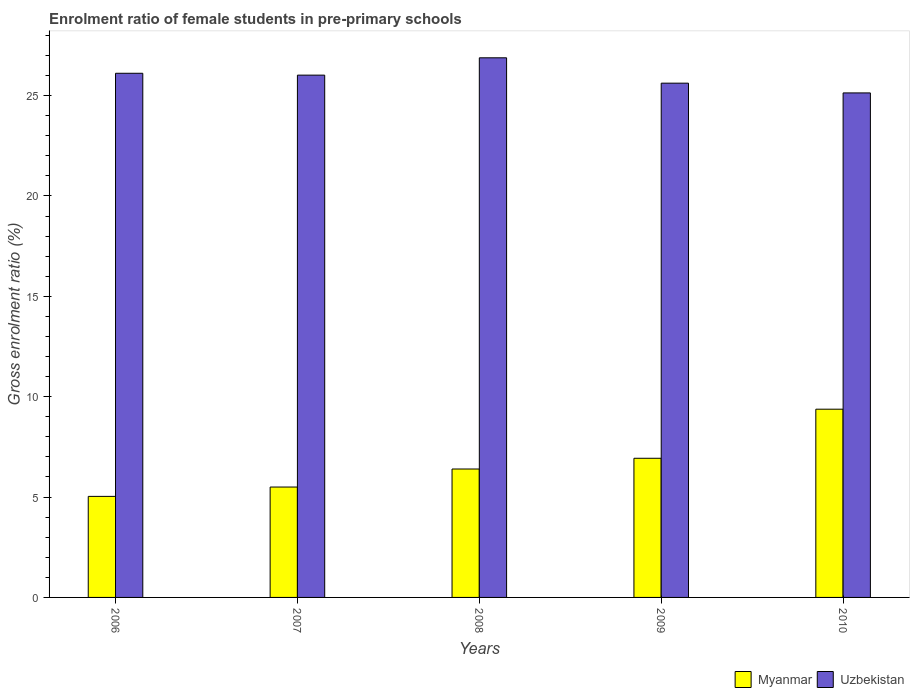How many groups of bars are there?
Provide a succinct answer. 5. Are the number of bars per tick equal to the number of legend labels?
Provide a short and direct response. Yes. Are the number of bars on each tick of the X-axis equal?
Your response must be concise. Yes. How many bars are there on the 2nd tick from the left?
Make the answer very short. 2. How many bars are there on the 1st tick from the right?
Offer a terse response. 2. What is the label of the 1st group of bars from the left?
Provide a succinct answer. 2006. In how many cases, is the number of bars for a given year not equal to the number of legend labels?
Your response must be concise. 0. What is the enrolment ratio of female students in pre-primary schools in Uzbekistan in 2008?
Keep it short and to the point. 26.88. Across all years, what is the maximum enrolment ratio of female students in pre-primary schools in Myanmar?
Your answer should be compact. 9.38. Across all years, what is the minimum enrolment ratio of female students in pre-primary schools in Uzbekistan?
Ensure brevity in your answer.  25.13. What is the total enrolment ratio of female students in pre-primary schools in Myanmar in the graph?
Give a very brief answer. 33.24. What is the difference between the enrolment ratio of female students in pre-primary schools in Uzbekistan in 2008 and that in 2010?
Your answer should be very brief. 1.75. What is the difference between the enrolment ratio of female students in pre-primary schools in Myanmar in 2008 and the enrolment ratio of female students in pre-primary schools in Uzbekistan in 2006?
Ensure brevity in your answer.  -19.71. What is the average enrolment ratio of female students in pre-primary schools in Uzbekistan per year?
Your answer should be compact. 25.95. In the year 2010, what is the difference between the enrolment ratio of female students in pre-primary schools in Uzbekistan and enrolment ratio of female students in pre-primary schools in Myanmar?
Make the answer very short. 15.76. What is the ratio of the enrolment ratio of female students in pre-primary schools in Uzbekistan in 2006 to that in 2007?
Your answer should be compact. 1. What is the difference between the highest and the second highest enrolment ratio of female students in pre-primary schools in Myanmar?
Keep it short and to the point. 2.44. What is the difference between the highest and the lowest enrolment ratio of female students in pre-primary schools in Uzbekistan?
Provide a short and direct response. 1.75. In how many years, is the enrolment ratio of female students in pre-primary schools in Uzbekistan greater than the average enrolment ratio of female students in pre-primary schools in Uzbekistan taken over all years?
Give a very brief answer. 3. Is the sum of the enrolment ratio of female students in pre-primary schools in Myanmar in 2009 and 2010 greater than the maximum enrolment ratio of female students in pre-primary schools in Uzbekistan across all years?
Offer a terse response. No. What does the 2nd bar from the left in 2009 represents?
Offer a terse response. Uzbekistan. What does the 1st bar from the right in 2010 represents?
Provide a short and direct response. Uzbekistan. How many bars are there?
Your response must be concise. 10. Are all the bars in the graph horizontal?
Keep it short and to the point. No. What is the difference between two consecutive major ticks on the Y-axis?
Ensure brevity in your answer.  5. Where does the legend appear in the graph?
Provide a succinct answer. Bottom right. How are the legend labels stacked?
Provide a succinct answer. Horizontal. What is the title of the graph?
Offer a very short reply. Enrolment ratio of female students in pre-primary schools. Does "Zimbabwe" appear as one of the legend labels in the graph?
Give a very brief answer. No. What is the label or title of the X-axis?
Offer a terse response. Years. What is the label or title of the Y-axis?
Make the answer very short. Gross enrolment ratio (%). What is the Gross enrolment ratio (%) of Myanmar in 2006?
Keep it short and to the point. 5.03. What is the Gross enrolment ratio (%) in Uzbekistan in 2006?
Your answer should be very brief. 26.11. What is the Gross enrolment ratio (%) in Myanmar in 2007?
Your answer should be compact. 5.5. What is the Gross enrolment ratio (%) in Uzbekistan in 2007?
Ensure brevity in your answer.  26.02. What is the Gross enrolment ratio (%) in Myanmar in 2008?
Provide a short and direct response. 6.4. What is the Gross enrolment ratio (%) of Uzbekistan in 2008?
Provide a short and direct response. 26.88. What is the Gross enrolment ratio (%) in Myanmar in 2009?
Offer a terse response. 6.93. What is the Gross enrolment ratio (%) in Uzbekistan in 2009?
Offer a terse response. 25.62. What is the Gross enrolment ratio (%) of Myanmar in 2010?
Provide a short and direct response. 9.38. What is the Gross enrolment ratio (%) of Uzbekistan in 2010?
Provide a short and direct response. 25.13. Across all years, what is the maximum Gross enrolment ratio (%) in Myanmar?
Give a very brief answer. 9.38. Across all years, what is the maximum Gross enrolment ratio (%) in Uzbekistan?
Give a very brief answer. 26.88. Across all years, what is the minimum Gross enrolment ratio (%) of Myanmar?
Your answer should be very brief. 5.03. Across all years, what is the minimum Gross enrolment ratio (%) of Uzbekistan?
Your answer should be compact. 25.13. What is the total Gross enrolment ratio (%) of Myanmar in the graph?
Your answer should be very brief. 33.24. What is the total Gross enrolment ratio (%) of Uzbekistan in the graph?
Your response must be concise. 129.77. What is the difference between the Gross enrolment ratio (%) in Myanmar in 2006 and that in 2007?
Offer a very short reply. -0.47. What is the difference between the Gross enrolment ratio (%) of Uzbekistan in 2006 and that in 2007?
Give a very brief answer. 0.09. What is the difference between the Gross enrolment ratio (%) of Myanmar in 2006 and that in 2008?
Offer a very short reply. -1.36. What is the difference between the Gross enrolment ratio (%) in Uzbekistan in 2006 and that in 2008?
Offer a terse response. -0.77. What is the difference between the Gross enrolment ratio (%) in Myanmar in 2006 and that in 2009?
Give a very brief answer. -1.9. What is the difference between the Gross enrolment ratio (%) of Uzbekistan in 2006 and that in 2009?
Give a very brief answer. 0.49. What is the difference between the Gross enrolment ratio (%) of Myanmar in 2006 and that in 2010?
Offer a terse response. -4.34. What is the difference between the Gross enrolment ratio (%) of Uzbekistan in 2006 and that in 2010?
Provide a short and direct response. 0.98. What is the difference between the Gross enrolment ratio (%) of Myanmar in 2007 and that in 2008?
Provide a succinct answer. -0.9. What is the difference between the Gross enrolment ratio (%) of Uzbekistan in 2007 and that in 2008?
Offer a very short reply. -0.86. What is the difference between the Gross enrolment ratio (%) of Myanmar in 2007 and that in 2009?
Offer a very short reply. -1.43. What is the difference between the Gross enrolment ratio (%) in Uzbekistan in 2007 and that in 2009?
Keep it short and to the point. 0.4. What is the difference between the Gross enrolment ratio (%) in Myanmar in 2007 and that in 2010?
Make the answer very short. -3.88. What is the difference between the Gross enrolment ratio (%) of Uzbekistan in 2007 and that in 2010?
Make the answer very short. 0.89. What is the difference between the Gross enrolment ratio (%) in Myanmar in 2008 and that in 2009?
Ensure brevity in your answer.  -0.53. What is the difference between the Gross enrolment ratio (%) of Uzbekistan in 2008 and that in 2009?
Your answer should be compact. 1.26. What is the difference between the Gross enrolment ratio (%) in Myanmar in 2008 and that in 2010?
Ensure brevity in your answer.  -2.98. What is the difference between the Gross enrolment ratio (%) in Uzbekistan in 2008 and that in 2010?
Offer a very short reply. 1.75. What is the difference between the Gross enrolment ratio (%) in Myanmar in 2009 and that in 2010?
Offer a very short reply. -2.44. What is the difference between the Gross enrolment ratio (%) of Uzbekistan in 2009 and that in 2010?
Keep it short and to the point. 0.49. What is the difference between the Gross enrolment ratio (%) in Myanmar in 2006 and the Gross enrolment ratio (%) in Uzbekistan in 2007?
Ensure brevity in your answer.  -20.99. What is the difference between the Gross enrolment ratio (%) of Myanmar in 2006 and the Gross enrolment ratio (%) of Uzbekistan in 2008?
Your response must be concise. -21.85. What is the difference between the Gross enrolment ratio (%) in Myanmar in 2006 and the Gross enrolment ratio (%) in Uzbekistan in 2009?
Offer a very short reply. -20.59. What is the difference between the Gross enrolment ratio (%) in Myanmar in 2006 and the Gross enrolment ratio (%) in Uzbekistan in 2010?
Your answer should be very brief. -20.1. What is the difference between the Gross enrolment ratio (%) in Myanmar in 2007 and the Gross enrolment ratio (%) in Uzbekistan in 2008?
Your answer should be very brief. -21.38. What is the difference between the Gross enrolment ratio (%) of Myanmar in 2007 and the Gross enrolment ratio (%) of Uzbekistan in 2009?
Offer a terse response. -20.12. What is the difference between the Gross enrolment ratio (%) of Myanmar in 2007 and the Gross enrolment ratio (%) of Uzbekistan in 2010?
Keep it short and to the point. -19.64. What is the difference between the Gross enrolment ratio (%) in Myanmar in 2008 and the Gross enrolment ratio (%) in Uzbekistan in 2009?
Keep it short and to the point. -19.22. What is the difference between the Gross enrolment ratio (%) of Myanmar in 2008 and the Gross enrolment ratio (%) of Uzbekistan in 2010?
Your response must be concise. -18.74. What is the difference between the Gross enrolment ratio (%) of Myanmar in 2009 and the Gross enrolment ratio (%) of Uzbekistan in 2010?
Your answer should be very brief. -18.2. What is the average Gross enrolment ratio (%) of Myanmar per year?
Your response must be concise. 6.65. What is the average Gross enrolment ratio (%) of Uzbekistan per year?
Give a very brief answer. 25.95. In the year 2006, what is the difference between the Gross enrolment ratio (%) of Myanmar and Gross enrolment ratio (%) of Uzbekistan?
Provide a short and direct response. -21.08. In the year 2007, what is the difference between the Gross enrolment ratio (%) in Myanmar and Gross enrolment ratio (%) in Uzbekistan?
Give a very brief answer. -20.52. In the year 2008, what is the difference between the Gross enrolment ratio (%) in Myanmar and Gross enrolment ratio (%) in Uzbekistan?
Your response must be concise. -20.49. In the year 2009, what is the difference between the Gross enrolment ratio (%) in Myanmar and Gross enrolment ratio (%) in Uzbekistan?
Your answer should be compact. -18.69. In the year 2010, what is the difference between the Gross enrolment ratio (%) in Myanmar and Gross enrolment ratio (%) in Uzbekistan?
Your answer should be very brief. -15.76. What is the ratio of the Gross enrolment ratio (%) of Myanmar in 2006 to that in 2007?
Your answer should be compact. 0.92. What is the ratio of the Gross enrolment ratio (%) of Uzbekistan in 2006 to that in 2007?
Your answer should be very brief. 1. What is the ratio of the Gross enrolment ratio (%) of Myanmar in 2006 to that in 2008?
Offer a terse response. 0.79. What is the ratio of the Gross enrolment ratio (%) of Uzbekistan in 2006 to that in 2008?
Offer a very short reply. 0.97. What is the ratio of the Gross enrolment ratio (%) of Myanmar in 2006 to that in 2009?
Your response must be concise. 0.73. What is the ratio of the Gross enrolment ratio (%) of Uzbekistan in 2006 to that in 2009?
Provide a succinct answer. 1.02. What is the ratio of the Gross enrolment ratio (%) in Myanmar in 2006 to that in 2010?
Ensure brevity in your answer.  0.54. What is the ratio of the Gross enrolment ratio (%) of Uzbekistan in 2006 to that in 2010?
Your answer should be compact. 1.04. What is the ratio of the Gross enrolment ratio (%) of Myanmar in 2007 to that in 2008?
Your answer should be very brief. 0.86. What is the ratio of the Gross enrolment ratio (%) of Uzbekistan in 2007 to that in 2008?
Provide a short and direct response. 0.97. What is the ratio of the Gross enrolment ratio (%) in Myanmar in 2007 to that in 2009?
Your response must be concise. 0.79. What is the ratio of the Gross enrolment ratio (%) of Uzbekistan in 2007 to that in 2009?
Offer a terse response. 1.02. What is the ratio of the Gross enrolment ratio (%) of Myanmar in 2007 to that in 2010?
Offer a terse response. 0.59. What is the ratio of the Gross enrolment ratio (%) in Uzbekistan in 2007 to that in 2010?
Provide a succinct answer. 1.04. What is the ratio of the Gross enrolment ratio (%) in Myanmar in 2008 to that in 2009?
Your response must be concise. 0.92. What is the ratio of the Gross enrolment ratio (%) of Uzbekistan in 2008 to that in 2009?
Your answer should be compact. 1.05. What is the ratio of the Gross enrolment ratio (%) of Myanmar in 2008 to that in 2010?
Offer a terse response. 0.68. What is the ratio of the Gross enrolment ratio (%) in Uzbekistan in 2008 to that in 2010?
Offer a terse response. 1.07. What is the ratio of the Gross enrolment ratio (%) of Myanmar in 2009 to that in 2010?
Provide a succinct answer. 0.74. What is the ratio of the Gross enrolment ratio (%) of Uzbekistan in 2009 to that in 2010?
Ensure brevity in your answer.  1.02. What is the difference between the highest and the second highest Gross enrolment ratio (%) in Myanmar?
Your answer should be compact. 2.44. What is the difference between the highest and the second highest Gross enrolment ratio (%) in Uzbekistan?
Your answer should be compact. 0.77. What is the difference between the highest and the lowest Gross enrolment ratio (%) in Myanmar?
Offer a very short reply. 4.34. What is the difference between the highest and the lowest Gross enrolment ratio (%) in Uzbekistan?
Your answer should be very brief. 1.75. 